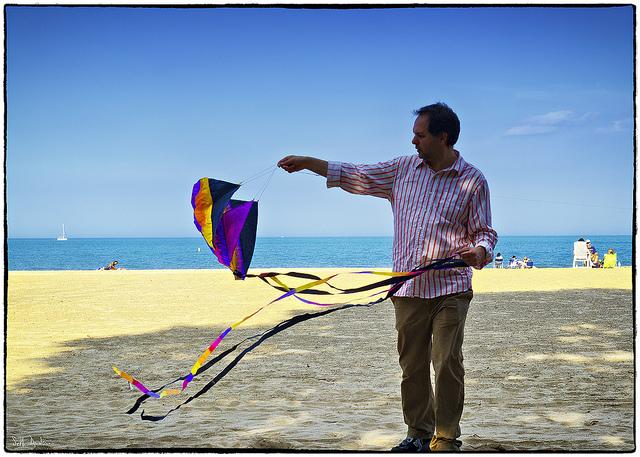Is there a boat visible?
Write a very short answer. Yes. Is it a sunny day?
Concise answer only. Yes. What is the man about to do?
Be succinct. Fly kite. 